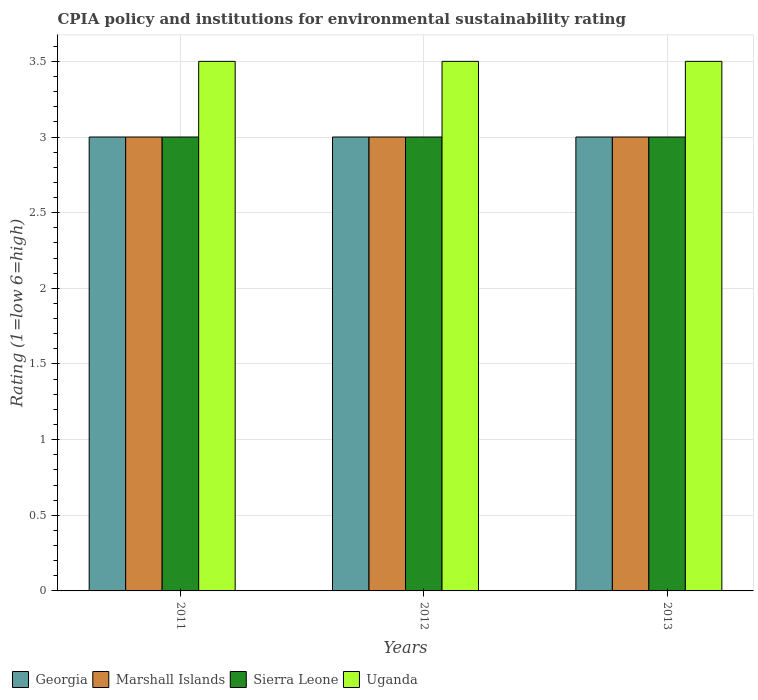How many different coloured bars are there?
Offer a terse response. 4. Are the number of bars on each tick of the X-axis equal?
Your answer should be very brief. Yes. How many bars are there on the 3rd tick from the left?
Your response must be concise. 4. How many bars are there on the 1st tick from the right?
Make the answer very short. 4. What is the label of the 3rd group of bars from the left?
Your response must be concise. 2013. What is the CPIA rating in Georgia in 2013?
Provide a short and direct response. 3. Across all years, what is the minimum CPIA rating in Uganda?
Make the answer very short. 3.5. In which year was the CPIA rating in Uganda maximum?
Offer a terse response. 2011. What is the total CPIA rating in Sierra Leone in the graph?
Keep it short and to the point. 9. What is the difference between the CPIA rating in Uganda in 2011 and that in 2013?
Provide a succinct answer. 0. What is the difference between the CPIA rating in Marshall Islands in 2011 and the CPIA rating in Uganda in 2013?
Ensure brevity in your answer.  -0.5. What is the average CPIA rating in Marshall Islands per year?
Make the answer very short. 3. What is the ratio of the CPIA rating in Uganda in 2012 to that in 2013?
Your answer should be compact. 1. Is the CPIA rating in Georgia in 2011 less than that in 2012?
Your response must be concise. No. Is the difference between the CPIA rating in Sierra Leone in 2012 and 2013 greater than the difference between the CPIA rating in Uganda in 2012 and 2013?
Your answer should be compact. No. What is the difference between the highest and the second highest CPIA rating in Uganda?
Your answer should be very brief. 0. In how many years, is the CPIA rating in Georgia greater than the average CPIA rating in Georgia taken over all years?
Your response must be concise. 0. Is the sum of the CPIA rating in Georgia in 2011 and 2013 greater than the maximum CPIA rating in Uganda across all years?
Give a very brief answer. Yes. What does the 3rd bar from the left in 2012 represents?
Provide a short and direct response. Sierra Leone. What does the 2nd bar from the right in 2012 represents?
Ensure brevity in your answer.  Sierra Leone. How many years are there in the graph?
Provide a succinct answer. 3. What is the difference between two consecutive major ticks on the Y-axis?
Your answer should be very brief. 0.5. Are the values on the major ticks of Y-axis written in scientific E-notation?
Offer a terse response. No. Does the graph contain grids?
Your answer should be very brief. Yes. Where does the legend appear in the graph?
Offer a terse response. Bottom left. How many legend labels are there?
Your answer should be compact. 4. What is the title of the graph?
Your answer should be very brief. CPIA policy and institutions for environmental sustainability rating. Does "Eritrea" appear as one of the legend labels in the graph?
Make the answer very short. No. What is the label or title of the X-axis?
Provide a short and direct response. Years. What is the label or title of the Y-axis?
Provide a succinct answer. Rating (1=low 6=high). What is the Rating (1=low 6=high) in Georgia in 2011?
Give a very brief answer. 3. What is the Rating (1=low 6=high) of Marshall Islands in 2011?
Your answer should be very brief. 3. What is the Rating (1=low 6=high) in Marshall Islands in 2012?
Provide a succinct answer. 3. What is the Rating (1=low 6=high) of Georgia in 2013?
Make the answer very short. 3. What is the Rating (1=low 6=high) of Marshall Islands in 2013?
Your answer should be compact. 3. Across all years, what is the maximum Rating (1=low 6=high) of Marshall Islands?
Provide a short and direct response. 3. Across all years, what is the maximum Rating (1=low 6=high) in Uganda?
Make the answer very short. 3.5. Across all years, what is the minimum Rating (1=low 6=high) in Georgia?
Give a very brief answer. 3. Across all years, what is the minimum Rating (1=low 6=high) of Uganda?
Your answer should be compact. 3.5. What is the total Rating (1=low 6=high) in Marshall Islands in the graph?
Offer a very short reply. 9. What is the difference between the Rating (1=low 6=high) in Georgia in 2011 and that in 2012?
Ensure brevity in your answer.  0. What is the difference between the Rating (1=low 6=high) of Marshall Islands in 2011 and that in 2012?
Ensure brevity in your answer.  0. What is the difference between the Rating (1=low 6=high) of Sierra Leone in 2011 and that in 2012?
Provide a succinct answer. 0. What is the difference between the Rating (1=low 6=high) of Uganda in 2011 and that in 2012?
Offer a very short reply. 0. What is the difference between the Rating (1=low 6=high) of Sierra Leone in 2011 and that in 2013?
Keep it short and to the point. 0. What is the difference between the Rating (1=low 6=high) of Georgia in 2012 and that in 2013?
Give a very brief answer. 0. What is the difference between the Rating (1=low 6=high) in Marshall Islands in 2012 and that in 2013?
Provide a short and direct response. 0. What is the difference between the Rating (1=low 6=high) in Uganda in 2012 and that in 2013?
Offer a very short reply. 0. What is the difference between the Rating (1=low 6=high) in Georgia in 2011 and the Rating (1=low 6=high) in Uganda in 2012?
Ensure brevity in your answer.  -0.5. What is the difference between the Rating (1=low 6=high) of Marshall Islands in 2011 and the Rating (1=low 6=high) of Sierra Leone in 2012?
Offer a very short reply. 0. What is the difference between the Rating (1=low 6=high) in Sierra Leone in 2011 and the Rating (1=low 6=high) in Uganda in 2012?
Keep it short and to the point. -0.5. What is the difference between the Rating (1=low 6=high) in Georgia in 2011 and the Rating (1=low 6=high) in Sierra Leone in 2013?
Offer a terse response. 0. What is the difference between the Rating (1=low 6=high) in Marshall Islands in 2011 and the Rating (1=low 6=high) in Sierra Leone in 2013?
Your answer should be very brief. 0. What is the difference between the Rating (1=low 6=high) of Sierra Leone in 2011 and the Rating (1=low 6=high) of Uganda in 2013?
Offer a terse response. -0.5. What is the difference between the Rating (1=low 6=high) in Georgia in 2012 and the Rating (1=low 6=high) in Marshall Islands in 2013?
Ensure brevity in your answer.  0. What is the difference between the Rating (1=low 6=high) in Georgia in 2012 and the Rating (1=low 6=high) in Sierra Leone in 2013?
Make the answer very short. 0. What is the difference between the Rating (1=low 6=high) in Georgia in 2012 and the Rating (1=low 6=high) in Uganda in 2013?
Your answer should be very brief. -0.5. What is the difference between the Rating (1=low 6=high) of Marshall Islands in 2012 and the Rating (1=low 6=high) of Sierra Leone in 2013?
Your answer should be compact. 0. What is the difference between the Rating (1=low 6=high) in Marshall Islands in 2012 and the Rating (1=low 6=high) in Uganda in 2013?
Offer a very short reply. -0.5. What is the average Rating (1=low 6=high) in Sierra Leone per year?
Ensure brevity in your answer.  3. What is the average Rating (1=low 6=high) of Uganda per year?
Provide a short and direct response. 3.5. In the year 2011, what is the difference between the Rating (1=low 6=high) of Georgia and Rating (1=low 6=high) of Marshall Islands?
Provide a succinct answer. 0. In the year 2011, what is the difference between the Rating (1=low 6=high) of Georgia and Rating (1=low 6=high) of Sierra Leone?
Keep it short and to the point. 0. In the year 2011, what is the difference between the Rating (1=low 6=high) of Georgia and Rating (1=low 6=high) of Uganda?
Provide a short and direct response. -0.5. In the year 2012, what is the difference between the Rating (1=low 6=high) in Georgia and Rating (1=low 6=high) in Marshall Islands?
Your answer should be very brief. 0. In the year 2012, what is the difference between the Rating (1=low 6=high) of Marshall Islands and Rating (1=low 6=high) of Sierra Leone?
Your answer should be very brief. 0. In the year 2012, what is the difference between the Rating (1=low 6=high) of Marshall Islands and Rating (1=low 6=high) of Uganda?
Provide a short and direct response. -0.5. In the year 2013, what is the difference between the Rating (1=low 6=high) of Georgia and Rating (1=low 6=high) of Marshall Islands?
Your response must be concise. 0. In the year 2013, what is the difference between the Rating (1=low 6=high) of Georgia and Rating (1=low 6=high) of Sierra Leone?
Keep it short and to the point. 0. In the year 2013, what is the difference between the Rating (1=low 6=high) of Georgia and Rating (1=low 6=high) of Uganda?
Make the answer very short. -0.5. In the year 2013, what is the difference between the Rating (1=low 6=high) of Marshall Islands and Rating (1=low 6=high) of Sierra Leone?
Make the answer very short. 0. In the year 2013, what is the difference between the Rating (1=low 6=high) of Marshall Islands and Rating (1=low 6=high) of Uganda?
Ensure brevity in your answer.  -0.5. In the year 2013, what is the difference between the Rating (1=low 6=high) in Sierra Leone and Rating (1=low 6=high) in Uganda?
Ensure brevity in your answer.  -0.5. What is the ratio of the Rating (1=low 6=high) of Georgia in 2011 to that in 2012?
Make the answer very short. 1. What is the ratio of the Rating (1=low 6=high) in Georgia in 2011 to that in 2013?
Your answer should be compact. 1. What is the ratio of the Rating (1=low 6=high) of Sierra Leone in 2011 to that in 2013?
Provide a short and direct response. 1. What is the ratio of the Rating (1=low 6=high) of Sierra Leone in 2012 to that in 2013?
Offer a very short reply. 1. What is the difference between the highest and the second highest Rating (1=low 6=high) in Marshall Islands?
Your answer should be very brief. 0. What is the difference between the highest and the second highest Rating (1=low 6=high) of Uganda?
Keep it short and to the point. 0. What is the difference between the highest and the lowest Rating (1=low 6=high) of Georgia?
Make the answer very short. 0. What is the difference between the highest and the lowest Rating (1=low 6=high) of Sierra Leone?
Your answer should be very brief. 0. What is the difference between the highest and the lowest Rating (1=low 6=high) in Uganda?
Your answer should be compact. 0. 